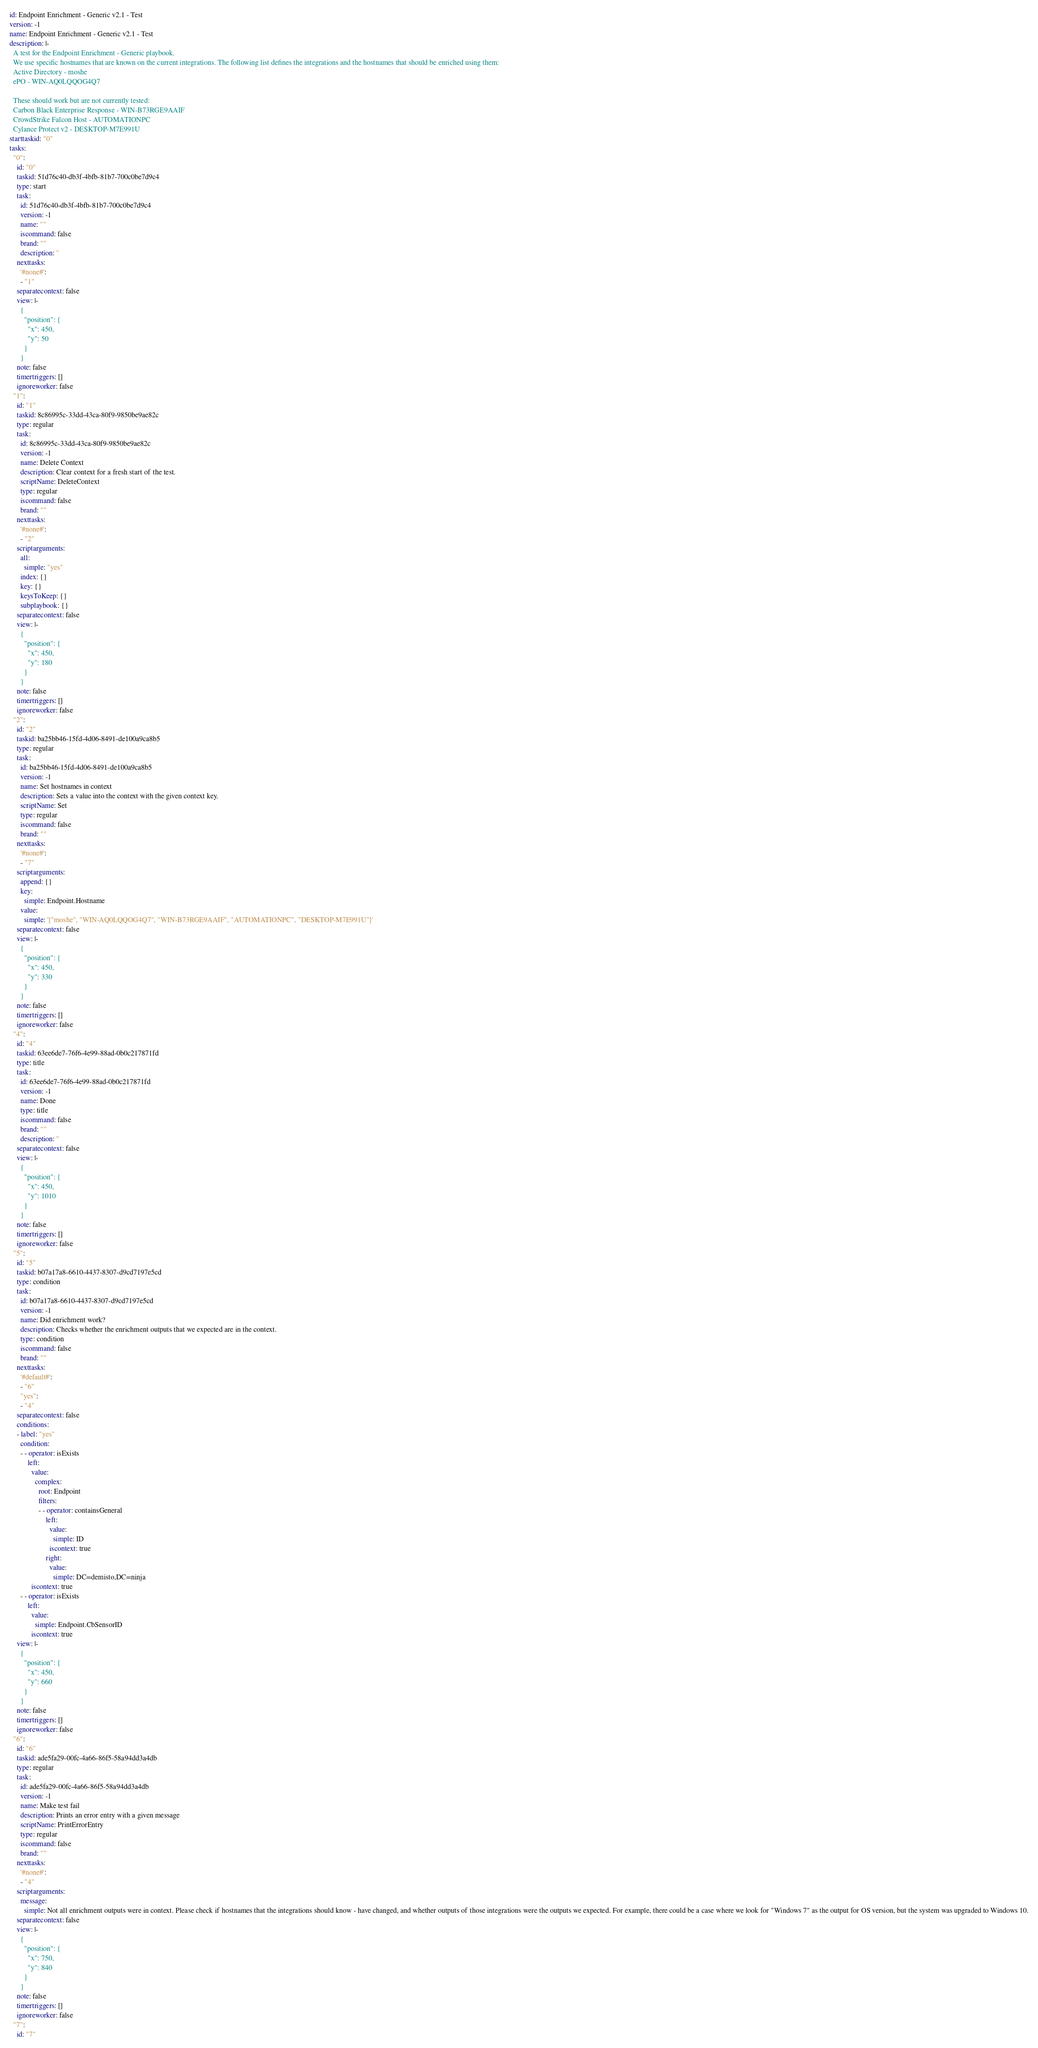Convert code to text. <code><loc_0><loc_0><loc_500><loc_500><_YAML_>id: Endpoint Enrichment - Generic v2.1 - Test
version: -1
name: Endpoint Enrichment - Generic v2.1 - Test
description: |-
  A test for the Endpoint Enrichment - Generic playbook.
  We use specific hostnames that are known on the current integrations. The following list defines the integrations and the hostnames that should be enriched using them:
  Active Directory - moshe
  ePO - WIN-AQ0LQQOG4Q7

  These should work but are not currently tested:
  Carbon Black Enterprise Response - WIN-B73RGE9AAIF
  CrowdStrike Falcon Host - AUTOMATIONPC
  Cylance Protect v2 - DESKTOP-M7E991U
starttaskid: "0"
tasks:
  "0":
    id: "0"
    taskid: 51d76c40-db3f-4bfb-81b7-700c0be7d9c4
    type: start
    task:
      id: 51d76c40-db3f-4bfb-81b7-700c0be7d9c4
      version: -1
      name: ""
      iscommand: false
      brand: ""
      description: ''
    nexttasks:
      '#none#':
      - "1"
    separatecontext: false
    view: |-
      {
        "position": {
          "x": 450,
          "y": 50
        }
      }
    note: false
    timertriggers: []
    ignoreworker: false
  "1":
    id: "1"
    taskid: 8c86995c-33dd-43ca-80f9-9850be9ae82c
    type: regular
    task:
      id: 8c86995c-33dd-43ca-80f9-9850be9ae82c
      version: -1
      name: Delete Context
      description: Clear context for a fresh start of the test.
      scriptName: DeleteContext
      type: regular
      iscommand: false
      brand: ""
    nexttasks:
      '#none#':
      - "2"
    scriptarguments:
      all:
        simple: "yes"
      index: {}
      key: {}
      keysToKeep: {}
      subplaybook: {}
    separatecontext: false
    view: |-
      {
        "position": {
          "x": 450,
          "y": 180
        }
      }
    note: false
    timertriggers: []
    ignoreworker: false
  "2":
    id: "2"
    taskid: ba25bb46-15fd-4d06-8491-de100a9ca8b5
    type: regular
    task:
      id: ba25bb46-15fd-4d06-8491-de100a9ca8b5
      version: -1
      name: Set hostnames in context
      description: Sets a value into the context with the given context key.
      scriptName: Set
      type: regular
      iscommand: false
      brand: ""
    nexttasks:
      '#none#':
      - "7"
    scriptarguments:
      append: {}
      key:
        simple: Endpoint.Hostname
      value:
        simple: '["moshe", "WIN-AQ0LQQOG4Q7", "WIN-B73RGE9AAIF", "AUTOMATIONPC", "DESKTOP-M7E991U"]'
    separatecontext: false
    view: |-
      {
        "position": {
          "x": 450,
          "y": 330
        }
      }
    note: false
    timertriggers: []
    ignoreworker: false
  "4":
    id: "4"
    taskid: 63ee6de7-76f6-4e99-88ad-0b0c217871fd
    type: title
    task:
      id: 63ee6de7-76f6-4e99-88ad-0b0c217871fd
      version: -1
      name: Done
      type: title
      iscommand: false
      brand: ""
      description: ''
    separatecontext: false
    view: |-
      {
        "position": {
          "x": 450,
          "y": 1010
        }
      }
    note: false
    timertriggers: []
    ignoreworker: false
  "5":
    id: "5"
    taskid: b07a17a8-6610-4437-8307-d9cd7197e5cd
    type: condition
    task:
      id: b07a17a8-6610-4437-8307-d9cd7197e5cd
      version: -1
      name: Did enrichment work?
      description: Checks whether the enrichment outputs that we expected are in the context.
      type: condition
      iscommand: false
      brand: ""
    nexttasks:
      '#default#':
      - "6"
      "yes":
      - "4"
    separatecontext: false
    conditions:
    - label: "yes"
      condition:
      - - operator: isExists
          left:
            value:
              complex:
                root: Endpoint
                filters:
                - - operator: containsGeneral
                    left:
                      value:
                        simple: ID
                      iscontext: true
                    right:
                      value:
                        simple: DC=demisto,DC=ninja
            iscontext: true
      - - operator: isExists
          left:
            value:
              simple: Endpoint.CbSensorID
            iscontext: true
    view: |-
      {
        "position": {
          "x": 450,
          "y": 660
        }
      }
    note: false
    timertriggers: []
    ignoreworker: false
  "6":
    id: "6"
    taskid: ade5fa29-00fc-4a66-86f5-58a94dd3a4db
    type: regular
    task:
      id: ade5fa29-00fc-4a66-86f5-58a94dd3a4db
      version: -1
      name: Make test fail
      description: Prints an error entry with a given message
      scriptName: PrintErrorEntry
      type: regular
      iscommand: false
      brand: ""
    nexttasks:
      '#none#':
      - "4"
    scriptarguments:
      message:
        simple: Not all enrichment outputs were in context. Please check if hostnames that the integrations should know - have changed, and whether outputs of those integrations were the outputs we expected. For example, there could be a case where we look for "Windows 7" as the output for OS version, but the system was upgraded to Windows 10.
    separatecontext: false
    view: |-
      {
        "position": {
          "x": 750,
          "y": 840
        }
      }
    note: false
    timertriggers: []
    ignoreworker: false
  "7":
    id: "7"</code> 